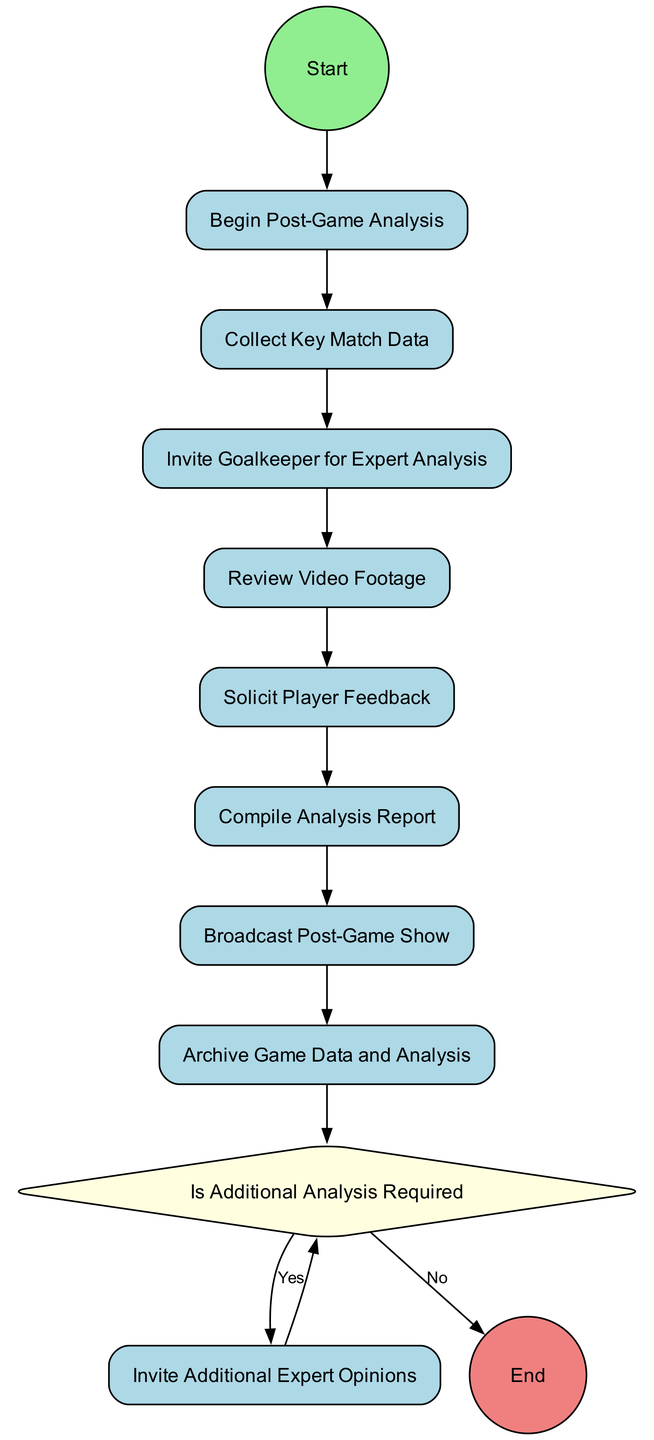What is the first activity in the diagram? The first activity listed in the sequence of the diagram is "Collect Key Match Data" which follows the start event.
Answer: Collect Key Match Data How many activities are represented in the diagram? There are a total of 6 activities outlined before the decision point including the additional activity.
Answer: 6 Which activity follows "Solicit Player Feedback"? After "Solicit Player Feedback," the next activity is "Compile Analysis Report," which combines feedback with match data.
Answer: Compile Analysis Report What happens if the decision "Is Additional Analysis Required" is answered with "No"? If the decision is "No," the next step is to "Complete Post-Game Analysis," which signifies the conclusion of the process.
Answer: Complete Post-Game Analysis What is the final event in the diagram? The final event that indicates the completion of the entire process is labeled "Complete Post-Game Analysis" and comes after the activities and decision.
Answer: Complete Post-Game Analysis How many branches are there in the decision "Is Additional Analysis Required"? There are two branches stemming from this decision: "Yes" and "No," reflecting the possible outcomes of the analysis requirement.
Answer: 2 What is the purpose of inviting the goalkeeper for expert analysis? The purpose is to receive the Goalkeeper's insights specifically regarding defensive plays and saves, which adds depth to the analysis.
Answer: Expert Analysis What is done with the game data and analysis after completion? After the post-game analysis is complete, the data and analysis reports are archived for future reference, ensuring they are accessible later.
Answer: Archive Game Data and Analysis 